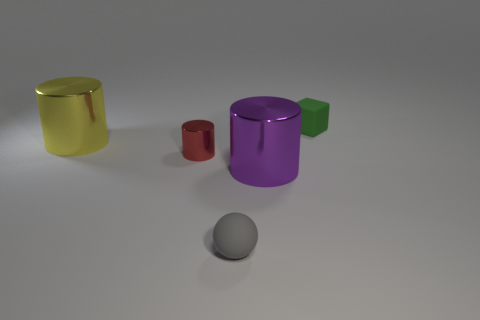There is a rubber thing in front of the rubber thing behind the small rubber sphere; what number of big yellow metal objects are in front of it?
Provide a succinct answer. 0. How many things are right of the big yellow cylinder and behind the small gray rubber thing?
Your response must be concise. 3. Is there any other thing that has the same color as the small rubber sphere?
Make the answer very short. No. How many metallic things are small red things or large objects?
Offer a terse response. 3. There is a large thing that is to the right of the matte thing that is in front of the thing that is to the right of the large purple shiny object; what is its material?
Keep it short and to the point. Metal. What is the material of the cylinder right of the rubber object in front of the green cube?
Give a very brief answer. Metal. There is a object behind the big yellow shiny cylinder; is its size the same as the matte object on the left side of the small green cube?
Give a very brief answer. Yes. Are there any other things that have the same material as the tiny ball?
Offer a terse response. Yes. What number of tiny things are either purple metal objects or brown shiny spheres?
Your answer should be very brief. 0. How many objects are either cylinders in front of the yellow shiny object or gray matte spheres?
Give a very brief answer. 3. 